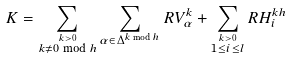<formula> <loc_0><loc_0><loc_500><loc_500>K = \sum _ { \stackrel { k > 0 } { k \neq 0 \bmod h } } \sum _ { \alpha \in \Delta ^ { k \bmod h } } R V _ { \alpha } ^ { k } + \sum _ { \stackrel { k > 0 } { 1 \leq i \leq l } } R H _ { i } ^ { k h }</formula> 